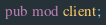<code> <loc_0><loc_0><loc_500><loc_500><_Rust_>
pub mod client;
</code> 